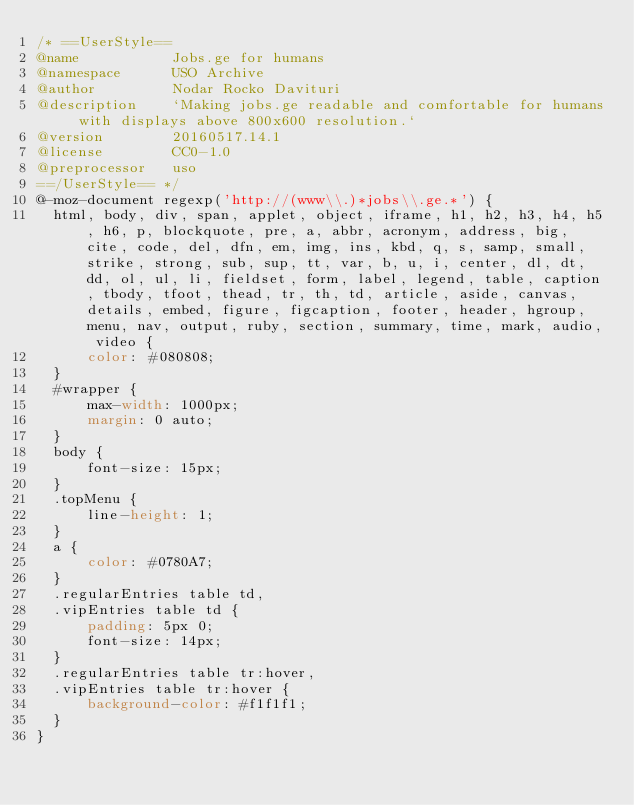<code> <loc_0><loc_0><loc_500><loc_500><_CSS_>/* ==UserStyle==
@name           Jobs.ge for humans
@namespace      USO Archive
@author         Nodar Rocko Davituri
@description    `Making jobs.ge readable and comfortable for humans with displays above 800x600 resolution.`
@version        20160517.14.1
@license        CC0-1.0
@preprocessor   uso
==/UserStyle== */
@-moz-document regexp('http://(www\\.)*jobs\\.ge.*') {
  html, body, div, span, applet, object, iframe, h1, h2, h3, h4, h5, h6, p, blockquote, pre, a, abbr, acronym, address, big, cite, code, del, dfn, em, img, ins, kbd, q, s, samp, small, strike, strong, sub, sup, tt, var, b, u, i, center, dl, dt, dd, ol, ul, li, fieldset, form, label, legend, table, caption, tbody, tfoot, thead, tr, th, td, article, aside, canvas, details, embed, figure, figcaption, footer, header, hgroup, menu, nav, output, ruby, section, summary, time, mark, audio, video {
      color: #080808;
  }
  #wrapper {
      max-width: 1000px;
      margin: 0 auto;
  }
  body {
      font-size: 15px;
  }
  .topMenu {
      line-height: 1;
  }
  a {
      color: #0780A7;
  }
  .regularEntries table td,
  .vipEntries table td {
      padding: 5px 0;
      font-size: 14px;
  }
  .regularEntries table tr:hover,
  .vipEntries table tr:hover {
      background-color: #f1f1f1;
  }
}</code> 